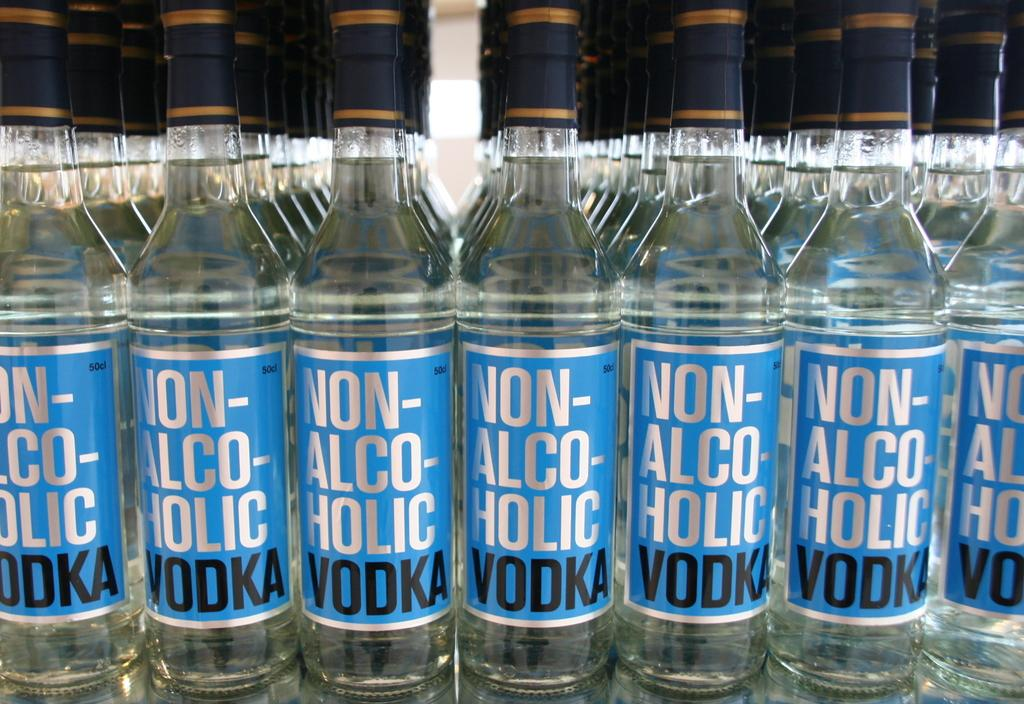<image>
Describe the image concisely. Bottles of Non-Alcoholic vodka all stacked in a line. 